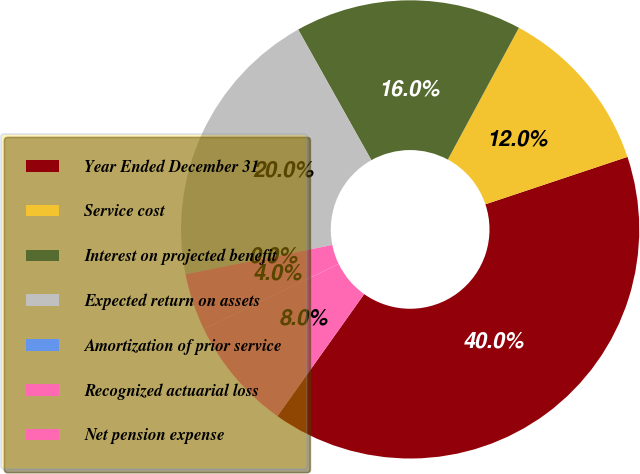Convert chart. <chart><loc_0><loc_0><loc_500><loc_500><pie_chart><fcel>Year Ended December 31<fcel>Service cost<fcel>Interest on projected benefit<fcel>Expected return on assets<fcel>Amortization of prior service<fcel>Recognized actuarial loss<fcel>Net pension expense<nl><fcel>39.96%<fcel>12.0%<fcel>16.0%<fcel>19.99%<fcel>0.02%<fcel>4.02%<fcel>8.01%<nl></chart> 